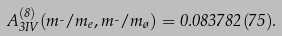Convert formula to latex. <formula><loc_0><loc_0><loc_500><loc_500>A _ { 3 I V } ^ { ( 8 ) } ( m _ { \mu } / m _ { e } , m _ { \mu } / m _ { \tau } ) = 0 . 0 8 3 7 8 2 ( 7 5 ) .</formula> 